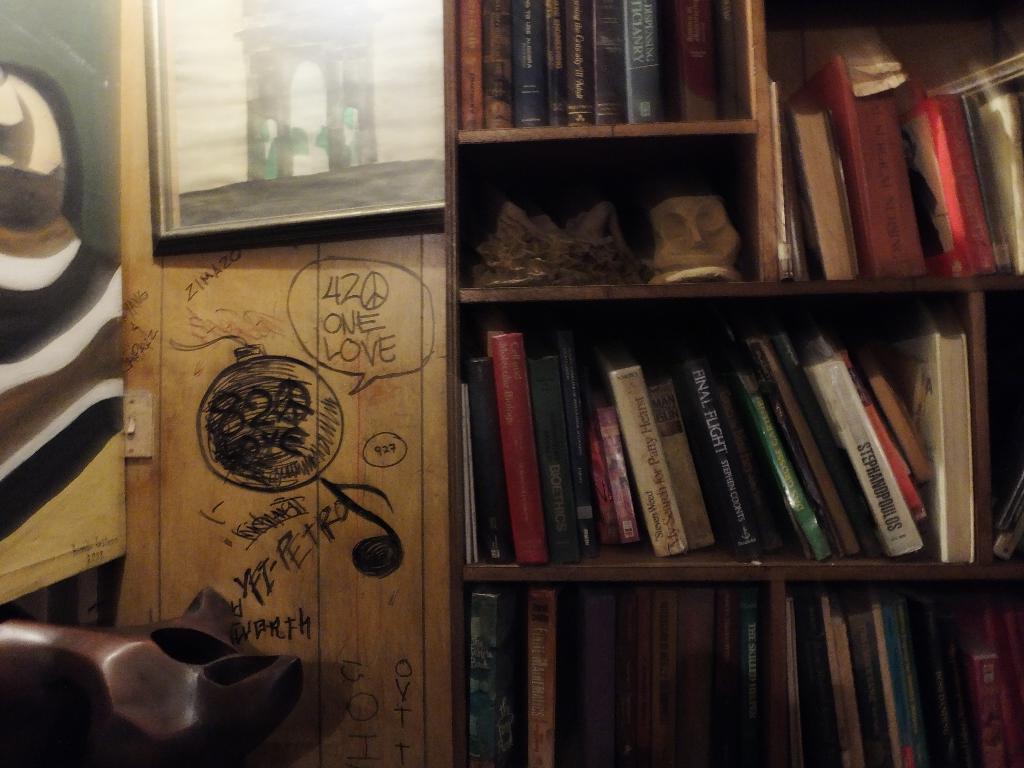In one or two sentences, can you explain what this image depicts? In this picture we can see few books and other things in the racks, at the top of the image we can see a frame. 